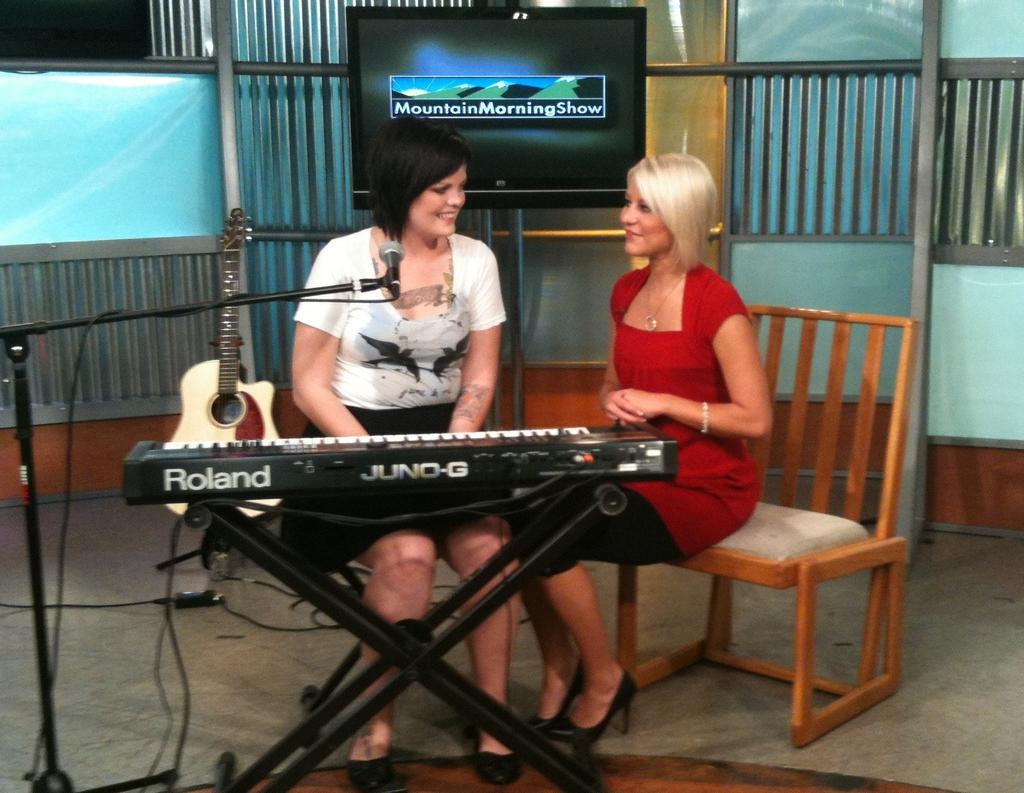What type of furniture can be seen in the image? There are chairs in the image. Who or what is present in the image? There are people and musical instruments in the image. What is at the bottom of the image? There is a floor at the bottom of the image. What can be seen on the wall in the background of the image? There is a screen on the wall in the background of the image. Can you tell me how many whips are being used by the people in the image? There are no whips present in the image. What reason might the people in the image have for being there? The image does not provide any information about the reason for the people being there. 